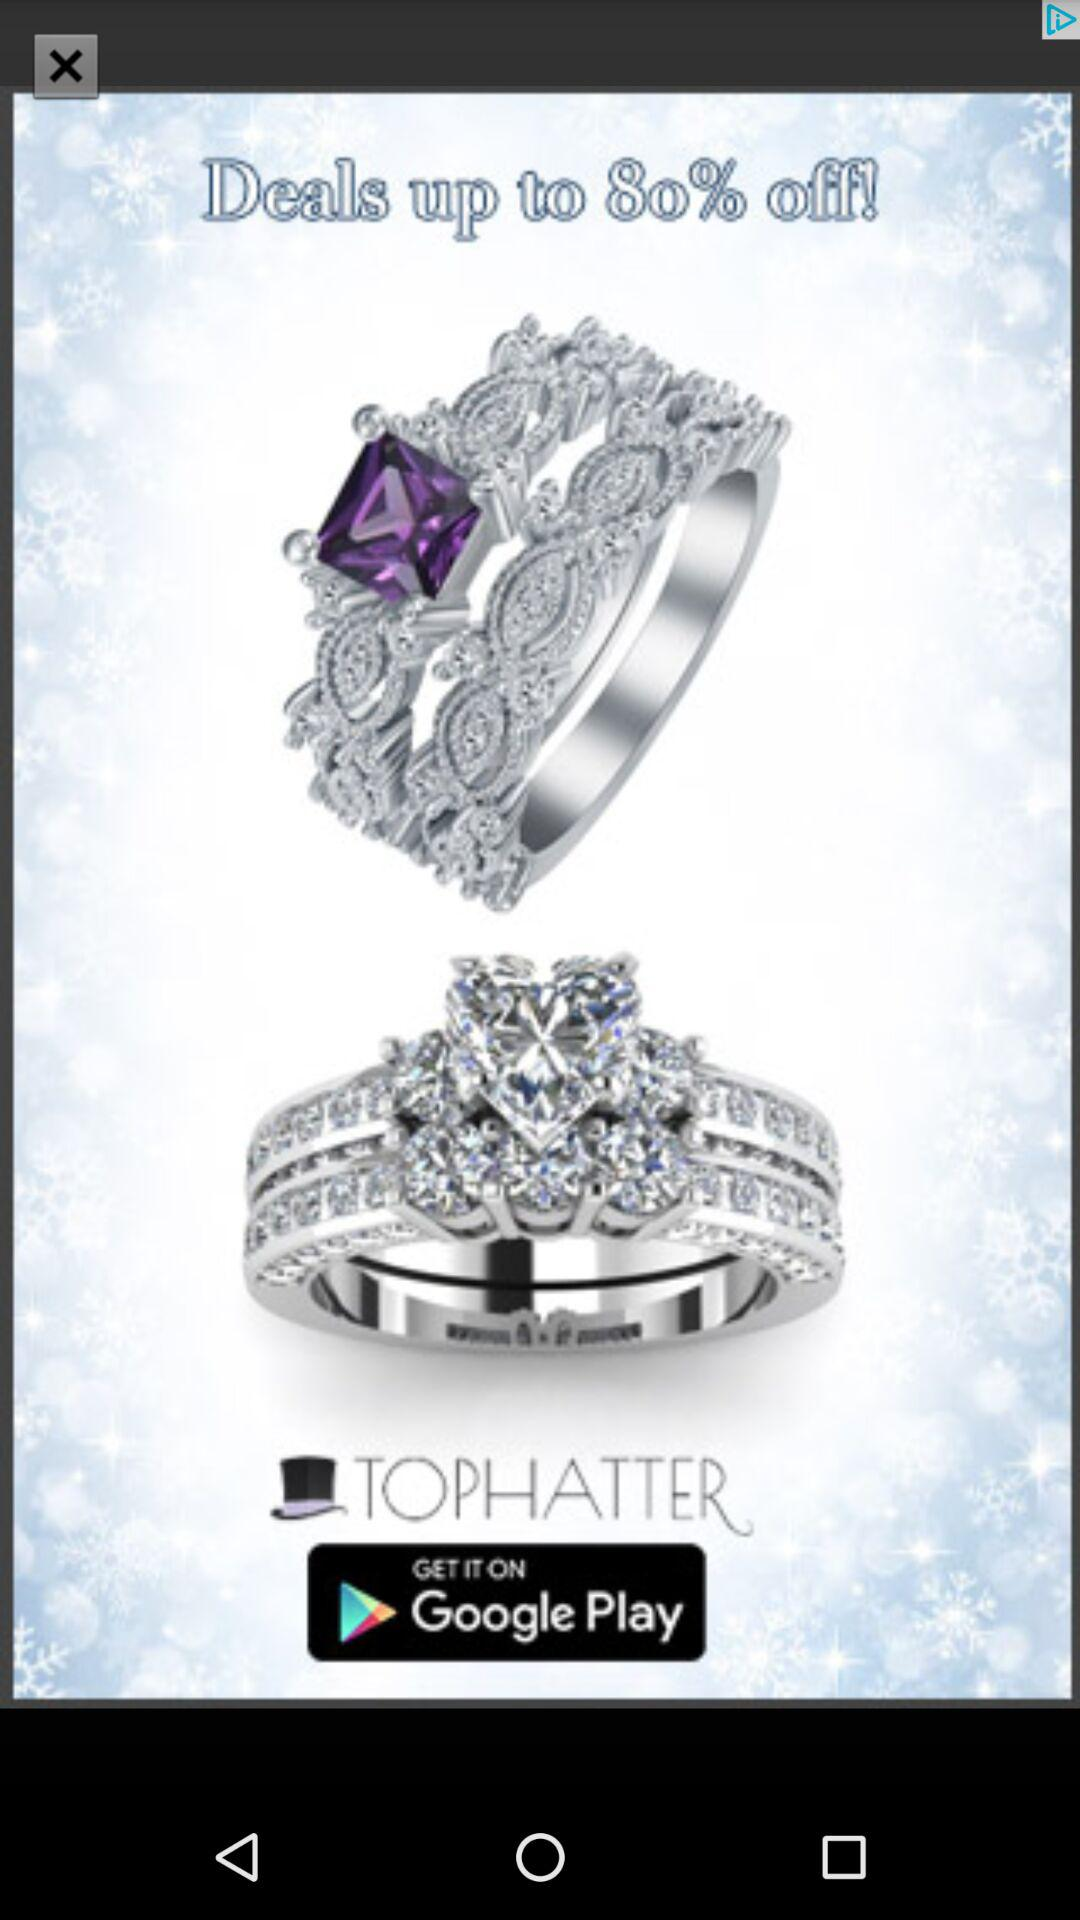How much is the discount on the deals? The discount on the deals is up to 80%. 